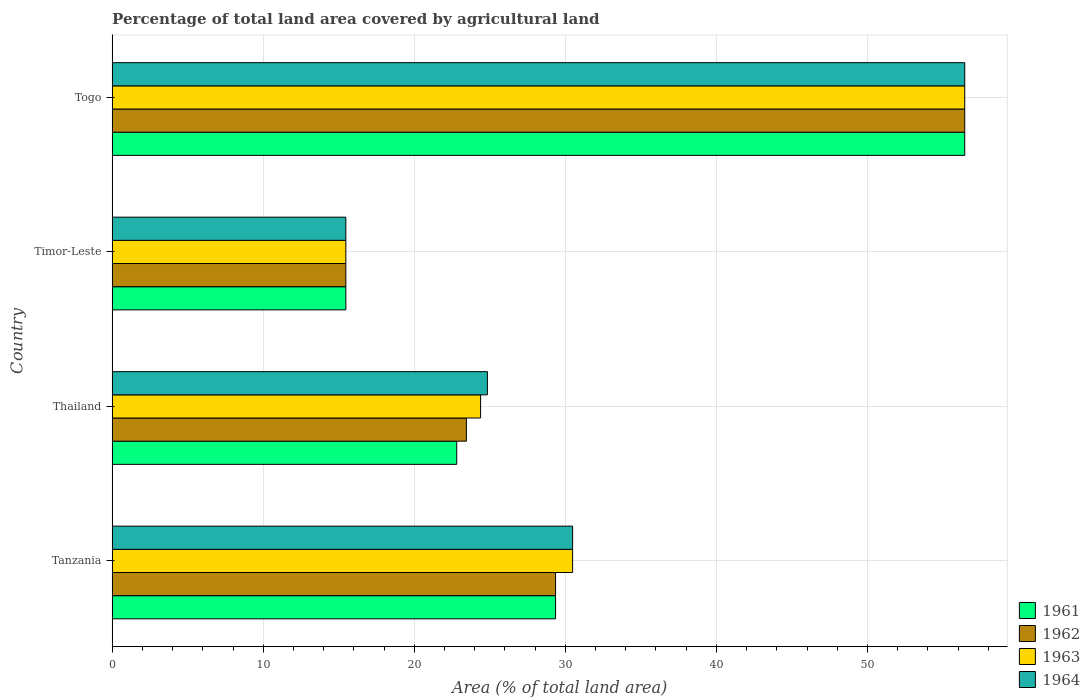How many different coloured bars are there?
Make the answer very short. 4. Are the number of bars on each tick of the Y-axis equal?
Offer a very short reply. Yes. How many bars are there on the 2nd tick from the top?
Ensure brevity in your answer.  4. What is the label of the 1st group of bars from the top?
Offer a very short reply. Togo. What is the percentage of agricultural land in 1962 in Thailand?
Your answer should be very brief. 23.45. Across all countries, what is the maximum percentage of agricultural land in 1962?
Offer a terse response. 56.44. Across all countries, what is the minimum percentage of agricultural land in 1962?
Your answer should be compact. 15.47. In which country was the percentage of agricultural land in 1961 maximum?
Your answer should be compact. Togo. In which country was the percentage of agricultural land in 1962 minimum?
Provide a short and direct response. Timor-Leste. What is the total percentage of agricultural land in 1961 in the graph?
Offer a terse response. 124.07. What is the difference between the percentage of agricultural land in 1963 in Tanzania and that in Thailand?
Make the answer very short. 6.09. What is the difference between the percentage of agricultural land in 1964 in Tanzania and the percentage of agricultural land in 1963 in Thailand?
Ensure brevity in your answer.  6.09. What is the average percentage of agricultural land in 1964 per country?
Your answer should be very brief. 31.81. What is the difference between the percentage of agricultural land in 1964 and percentage of agricultural land in 1963 in Timor-Leste?
Offer a terse response. 0. In how many countries, is the percentage of agricultural land in 1963 greater than 34 %?
Your response must be concise. 1. What is the ratio of the percentage of agricultural land in 1963 in Tanzania to that in Timor-Leste?
Your response must be concise. 1.97. Is the difference between the percentage of agricultural land in 1964 in Thailand and Timor-Leste greater than the difference between the percentage of agricultural land in 1963 in Thailand and Timor-Leste?
Your answer should be compact. Yes. What is the difference between the highest and the second highest percentage of agricultural land in 1964?
Your answer should be compact. 25.96. What is the difference between the highest and the lowest percentage of agricultural land in 1963?
Your answer should be very brief. 40.98. Is the sum of the percentage of agricultural land in 1962 in Tanzania and Togo greater than the maximum percentage of agricultural land in 1961 across all countries?
Keep it short and to the point. Yes. What does the 1st bar from the top in Thailand represents?
Your response must be concise. 1964. What does the 4th bar from the bottom in Thailand represents?
Offer a terse response. 1964. What is the difference between two consecutive major ticks on the X-axis?
Offer a very short reply. 10. How many legend labels are there?
Make the answer very short. 4. How are the legend labels stacked?
Give a very brief answer. Vertical. What is the title of the graph?
Keep it short and to the point. Percentage of total land area covered by agricultural land. Does "1961" appear as one of the legend labels in the graph?
Give a very brief answer. Yes. What is the label or title of the X-axis?
Ensure brevity in your answer.  Area (% of total land area). What is the Area (% of total land area) in 1961 in Tanzania?
Keep it short and to the point. 29.35. What is the Area (% of total land area) in 1962 in Tanzania?
Keep it short and to the point. 29.35. What is the Area (% of total land area) of 1963 in Tanzania?
Your response must be concise. 30.48. What is the Area (% of total land area) in 1964 in Tanzania?
Keep it short and to the point. 30.48. What is the Area (% of total land area) in 1961 in Thailand?
Offer a terse response. 22.81. What is the Area (% of total land area) of 1962 in Thailand?
Your response must be concise. 23.45. What is the Area (% of total land area) of 1963 in Thailand?
Give a very brief answer. 24.39. What is the Area (% of total land area) of 1964 in Thailand?
Offer a very short reply. 24.84. What is the Area (% of total land area) in 1961 in Timor-Leste?
Your answer should be very brief. 15.47. What is the Area (% of total land area) of 1962 in Timor-Leste?
Provide a succinct answer. 15.47. What is the Area (% of total land area) of 1963 in Timor-Leste?
Provide a short and direct response. 15.47. What is the Area (% of total land area) in 1964 in Timor-Leste?
Ensure brevity in your answer.  15.47. What is the Area (% of total land area) in 1961 in Togo?
Your response must be concise. 56.44. What is the Area (% of total land area) in 1962 in Togo?
Your answer should be very brief. 56.44. What is the Area (% of total land area) of 1963 in Togo?
Provide a short and direct response. 56.44. What is the Area (% of total land area) in 1964 in Togo?
Your answer should be very brief. 56.44. Across all countries, what is the maximum Area (% of total land area) in 1961?
Give a very brief answer. 56.44. Across all countries, what is the maximum Area (% of total land area) of 1962?
Provide a short and direct response. 56.44. Across all countries, what is the maximum Area (% of total land area) of 1963?
Your answer should be very brief. 56.44. Across all countries, what is the maximum Area (% of total land area) of 1964?
Make the answer very short. 56.44. Across all countries, what is the minimum Area (% of total land area) in 1961?
Provide a short and direct response. 15.47. Across all countries, what is the minimum Area (% of total land area) of 1962?
Offer a very short reply. 15.47. Across all countries, what is the minimum Area (% of total land area) in 1963?
Your answer should be compact. 15.47. Across all countries, what is the minimum Area (% of total land area) of 1964?
Your answer should be compact. 15.47. What is the total Area (% of total land area) of 1961 in the graph?
Keep it short and to the point. 124.07. What is the total Area (% of total land area) of 1962 in the graph?
Your answer should be compact. 124.71. What is the total Area (% of total land area) in 1963 in the graph?
Your answer should be compact. 126.78. What is the total Area (% of total land area) in 1964 in the graph?
Provide a short and direct response. 127.23. What is the difference between the Area (% of total land area) of 1961 in Tanzania and that in Thailand?
Ensure brevity in your answer.  6.54. What is the difference between the Area (% of total land area) in 1962 in Tanzania and that in Thailand?
Your answer should be very brief. 5.9. What is the difference between the Area (% of total land area) in 1963 in Tanzania and that in Thailand?
Provide a succinct answer. 6.09. What is the difference between the Area (% of total land area) of 1964 in Tanzania and that in Thailand?
Ensure brevity in your answer.  5.64. What is the difference between the Area (% of total land area) of 1961 in Tanzania and that in Timor-Leste?
Ensure brevity in your answer.  13.88. What is the difference between the Area (% of total land area) in 1962 in Tanzania and that in Timor-Leste?
Provide a succinct answer. 13.88. What is the difference between the Area (% of total land area) in 1963 in Tanzania and that in Timor-Leste?
Give a very brief answer. 15.01. What is the difference between the Area (% of total land area) of 1964 in Tanzania and that in Timor-Leste?
Provide a short and direct response. 15.01. What is the difference between the Area (% of total land area) in 1961 in Tanzania and that in Togo?
Provide a succinct answer. -27.09. What is the difference between the Area (% of total land area) of 1962 in Tanzania and that in Togo?
Make the answer very short. -27.09. What is the difference between the Area (% of total land area) of 1963 in Tanzania and that in Togo?
Offer a very short reply. -25.96. What is the difference between the Area (% of total land area) in 1964 in Tanzania and that in Togo?
Your response must be concise. -25.96. What is the difference between the Area (% of total land area) of 1961 in Thailand and that in Timor-Leste?
Keep it short and to the point. 7.34. What is the difference between the Area (% of total land area) of 1962 in Thailand and that in Timor-Leste?
Your answer should be compact. 7.98. What is the difference between the Area (% of total land area) of 1963 in Thailand and that in Timor-Leste?
Provide a succinct answer. 8.92. What is the difference between the Area (% of total land area) in 1964 in Thailand and that in Timor-Leste?
Provide a short and direct response. 9.37. What is the difference between the Area (% of total land area) in 1961 in Thailand and that in Togo?
Ensure brevity in your answer.  -33.63. What is the difference between the Area (% of total land area) in 1962 in Thailand and that in Togo?
Your answer should be compact. -32.99. What is the difference between the Area (% of total land area) in 1963 in Thailand and that in Togo?
Offer a very short reply. -32.06. What is the difference between the Area (% of total land area) in 1964 in Thailand and that in Togo?
Keep it short and to the point. -31.61. What is the difference between the Area (% of total land area) of 1961 in Timor-Leste and that in Togo?
Your response must be concise. -40.98. What is the difference between the Area (% of total land area) of 1962 in Timor-Leste and that in Togo?
Ensure brevity in your answer.  -40.98. What is the difference between the Area (% of total land area) in 1963 in Timor-Leste and that in Togo?
Your answer should be very brief. -40.98. What is the difference between the Area (% of total land area) of 1964 in Timor-Leste and that in Togo?
Your answer should be compact. -40.98. What is the difference between the Area (% of total land area) in 1961 in Tanzania and the Area (% of total land area) in 1962 in Thailand?
Ensure brevity in your answer.  5.9. What is the difference between the Area (% of total land area) in 1961 in Tanzania and the Area (% of total land area) in 1963 in Thailand?
Make the answer very short. 4.96. What is the difference between the Area (% of total land area) in 1961 in Tanzania and the Area (% of total land area) in 1964 in Thailand?
Make the answer very short. 4.51. What is the difference between the Area (% of total land area) in 1962 in Tanzania and the Area (% of total land area) in 1963 in Thailand?
Provide a succinct answer. 4.96. What is the difference between the Area (% of total land area) of 1962 in Tanzania and the Area (% of total land area) of 1964 in Thailand?
Offer a terse response. 4.51. What is the difference between the Area (% of total land area) of 1963 in Tanzania and the Area (% of total land area) of 1964 in Thailand?
Offer a very short reply. 5.64. What is the difference between the Area (% of total land area) of 1961 in Tanzania and the Area (% of total land area) of 1962 in Timor-Leste?
Offer a terse response. 13.88. What is the difference between the Area (% of total land area) of 1961 in Tanzania and the Area (% of total land area) of 1963 in Timor-Leste?
Ensure brevity in your answer.  13.88. What is the difference between the Area (% of total land area) of 1961 in Tanzania and the Area (% of total land area) of 1964 in Timor-Leste?
Give a very brief answer. 13.88. What is the difference between the Area (% of total land area) of 1962 in Tanzania and the Area (% of total land area) of 1963 in Timor-Leste?
Offer a very short reply. 13.88. What is the difference between the Area (% of total land area) of 1962 in Tanzania and the Area (% of total land area) of 1964 in Timor-Leste?
Your answer should be compact. 13.88. What is the difference between the Area (% of total land area) of 1963 in Tanzania and the Area (% of total land area) of 1964 in Timor-Leste?
Offer a very short reply. 15.01. What is the difference between the Area (% of total land area) of 1961 in Tanzania and the Area (% of total land area) of 1962 in Togo?
Keep it short and to the point. -27.09. What is the difference between the Area (% of total land area) in 1961 in Tanzania and the Area (% of total land area) in 1963 in Togo?
Offer a very short reply. -27.09. What is the difference between the Area (% of total land area) in 1961 in Tanzania and the Area (% of total land area) in 1964 in Togo?
Your answer should be compact. -27.09. What is the difference between the Area (% of total land area) of 1962 in Tanzania and the Area (% of total land area) of 1963 in Togo?
Your response must be concise. -27.09. What is the difference between the Area (% of total land area) in 1962 in Tanzania and the Area (% of total land area) in 1964 in Togo?
Keep it short and to the point. -27.09. What is the difference between the Area (% of total land area) of 1963 in Tanzania and the Area (% of total land area) of 1964 in Togo?
Your answer should be very brief. -25.96. What is the difference between the Area (% of total land area) in 1961 in Thailand and the Area (% of total land area) in 1962 in Timor-Leste?
Ensure brevity in your answer.  7.34. What is the difference between the Area (% of total land area) of 1961 in Thailand and the Area (% of total land area) of 1963 in Timor-Leste?
Ensure brevity in your answer.  7.34. What is the difference between the Area (% of total land area) in 1961 in Thailand and the Area (% of total land area) in 1964 in Timor-Leste?
Provide a succinct answer. 7.34. What is the difference between the Area (% of total land area) of 1962 in Thailand and the Area (% of total land area) of 1963 in Timor-Leste?
Give a very brief answer. 7.98. What is the difference between the Area (% of total land area) of 1962 in Thailand and the Area (% of total land area) of 1964 in Timor-Leste?
Give a very brief answer. 7.98. What is the difference between the Area (% of total land area) in 1963 in Thailand and the Area (% of total land area) in 1964 in Timor-Leste?
Offer a very short reply. 8.92. What is the difference between the Area (% of total land area) in 1961 in Thailand and the Area (% of total land area) in 1962 in Togo?
Your response must be concise. -33.63. What is the difference between the Area (% of total land area) of 1961 in Thailand and the Area (% of total land area) of 1963 in Togo?
Your response must be concise. -33.63. What is the difference between the Area (% of total land area) in 1961 in Thailand and the Area (% of total land area) in 1964 in Togo?
Offer a terse response. -33.63. What is the difference between the Area (% of total land area) of 1962 in Thailand and the Area (% of total land area) of 1963 in Togo?
Your response must be concise. -32.99. What is the difference between the Area (% of total land area) in 1962 in Thailand and the Area (% of total land area) in 1964 in Togo?
Offer a very short reply. -32.99. What is the difference between the Area (% of total land area) of 1963 in Thailand and the Area (% of total land area) of 1964 in Togo?
Ensure brevity in your answer.  -32.06. What is the difference between the Area (% of total land area) of 1961 in Timor-Leste and the Area (% of total land area) of 1962 in Togo?
Keep it short and to the point. -40.98. What is the difference between the Area (% of total land area) in 1961 in Timor-Leste and the Area (% of total land area) in 1963 in Togo?
Keep it short and to the point. -40.98. What is the difference between the Area (% of total land area) of 1961 in Timor-Leste and the Area (% of total land area) of 1964 in Togo?
Ensure brevity in your answer.  -40.98. What is the difference between the Area (% of total land area) in 1962 in Timor-Leste and the Area (% of total land area) in 1963 in Togo?
Your answer should be very brief. -40.98. What is the difference between the Area (% of total land area) in 1962 in Timor-Leste and the Area (% of total land area) in 1964 in Togo?
Provide a succinct answer. -40.98. What is the difference between the Area (% of total land area) in 1963 in Timor-Leste and the Area (% of total land area) in 1964 in Togo?
Your response must be concise. -40.98. What is the average Area (% of total land area) in 1961 per country?
Provide a short and direct response. 31.02. What is the average Area (% of total land area) in 1962 per country?
Provide a succinct answer. 31.18. What is the average Area (% of total land area) of 1963 per country?
Your answer should be compact. 31.7. What is the average Area (% of total land area) of 1964 per country?
Offer a very short reply. 31.81. What is the difference between the Area (% of total land area) in 1961 and Area (% of total land area) in 1963 in Tanzania?
Offer a terse response. -1.13. What is the difference between the Area (% of total land area) in 1961 and Area (% of total land area) in 1964 in Tanzania?
Keep it short and to the point. -1.13. What is the difference between the Area (% of total land area) in 1962 and Area (% of total land area) in 1963 in Tanzania?
Give a very brief answer. -1.13. What is the difference between the Area (% of total land area) in 1962 and Area (% of total land area) in 1964 in Tanzania?
Keep it short and to the point. -1.13. What is the difference between the Area (% of total land area) in 1963 and Area (% of total land area) in 1964 in Tanzania?
Offer a very short reply. 0. What is the difference between the Area (% of total land area) of 1961 and Area (% of total land area) of 1962 in Thailand?
Provide a short and direct response. -0.64. What is the difference between the Area (% of total land area) of 1961 and Area (% of total land area) of 1963 in Thailand?
Give a very brief answer. -1.58. What is the difference between the Area (% of total land area) of 1961 and Area (% of total land area) of 1964 in Thailand?
Your answer should be very brief. -2.03. What is the difference between the Area (% of total land area) in 1962 and Area (% of total land area) in 1963 in Thailand?
Provide a succinct answer. -0.94. What is the difference between the Area (% of total land area) of 1962 and Area (% of total land area) of 1964 in Thailand?
Your answer should be compact. -1.39. What is the difference between the Area (% of total land area) in 1963 and Area (% of total land area) in 1964 in Thailand?
Offer a terse response. -0.45. What is the difference between the Area (% of total land area) of 1961 and Area (% of total land area) of 1962 in Timor-Leste?
Your response must be concise. 0. What is the difference between the Area (% of total land area) of 1961 and Area (% of total land area) of 1963 in Timor-Leste?
Ensure brevity in your answer.  0. What is the difference between the Area (% of total land area) of 1961 and Area (% of total land area) of 1963 in Togo?
Your answer should be compact. 0. What is the difference between the Area (% of total land area) of 1961 and Area (% of total land area) of 1964 in Togo?
Your answer should be compact. 0. What is the difference between the Area (% of total land area) in 1962 and Area (% of total land area) in 1964 in Togo?
Offer a terse response. 0. What is the ratio of the Area (% of total land area) in 1961 in Tanzania to that in Thailand?
Ensure brevity in your answer.  1.29. What is the ratio of the Area (% of total land area) of 1962 in Tanzania to that in Thailand?
Your answer should be compact. 1.25. What is the ratio of the Area (% of total land area) of 1963 in Tanzania to that in Thailand?
Your response must be concise. 1.25. What is the ratio of the Area (% of total land area) of 1964 in Tanzania to that in Thailand?
Provide a short and direct response. 1.23. What is the ratio of the Area (% of total land area) of 1961 in Tanzania to that in Timor-Leste?
Your answer should be very brief. 1.9. What is the ratio of the Area (% of total land area) in 1962 in Tanzania to that in Timor-Leste?
Offer a terse response. 1.9. What is the ratio of the Area (% of total land area) in 1963 in Tanzania to that in Timor-Leste?
Keep it short and to the point. 1.97. What is the ratio of the Area (% of total land area) of 1964 in Tanzania to that in Timor-Leste?
Ensure brevity in your answer.  1.97. What is the ratio of the Area (% of total land area) in 1961 in Tanzania to that in Togo?
Your response must be concise. 0.52. What is the ratio of the Area (% of total land area) of 1962 in Tanzania to that in Togo?
Offer a terse response. 0.52. What is the ratio of the Area (% of total land area) of 1963 in Tanzania to that in Togo?
Ensure brevity in your answer.  0.54. What is the ratio of the Area (% of total land area) of 1964 in Tanzania to that in Togo?
Your answer should be very brief. 0.54. What is the ratio of the Area (% of total land area) in 1961 in Thailand to that in Timor-Leste?
Your response must be concise. 1.47. What is the ratio of the Area (% of total land area) in 1962 in Thailand to that in Timor-Leste?
Offer a very short reply. 1.52. What is the ratio of the Area (% of total land area) of 1963 in Thailand to that in Timor-Leste?
Your answer should be compact. 1.58. What is the ratio of the Area (% of total land area) of 1964 in Thailand to that in Timor-Leste?
Make the answer very short. 1.61. What is the ratio of the Area (% of total land area) of 1961 in Thailand to that in Togo?
Offer a very short reply. 0.4. What is the ratio of the Area (% of total land area) of 1962 in Thailand to that in Togo?
Provide a succinct answer. 0.42. What is the ratio of the Area (% of total land area) of 1963 in Thailand to that in Togo?
Provide a succinct answer. 0.43. What is the ratio of the Area (% of total land area) in 1964 in Thailand to that in Togo?
Your answer should be compact. 0.44. What is the ratio of the Area (% of total land area) in 1961 in Timor-Leste to that in Togo?
Provide a short and direct response. 0.27. What is the ratio of the Area (% of total land area) of 1962 in Timor-Leste to that in Togo?
Provide a short and direct response. 0.27. What is the ratio of the Area (% of total land area) in 1963 in Timor-Leste to that in Togo?
Give a very brief answer. 0.27. What is the ratio of the Area (% of total land area) in 1964 in Timor-Leste to that in Togo?
Offer a terse response. 0.27. What is the difference between the highest and the second highest Area (% of total land area) of 1961?
Make the answer very short. 27.09. What is the difference between the highest and the second highest Area (% of total land area) of 1962?
Offer a terse response. 27.09. What is the difference between the highest and the second highest Area (% of total land area) of 1963?
Keep it short and to the point. 25.96. What is the difference between the highest and the second highest Area (% of total land area) of 1964?
Provide a succinct answer. 25.96. What is the difference between the highest and the lowest Area (% of total land area) of 1961?
Keep it short and to the point. 40.98. What is the difference between the highest and the lowest Area (% of total land area) in 1962?
Make the answer very short. 40.98. What is the difference between the highest and the lowest Area (% of total land area) in 1963?
Ensure brevity in your answer.  40.98. What is the difference between the highest and the lowest Area (% of total land area) in 1964?
Your answer should be compact. 40.98. 